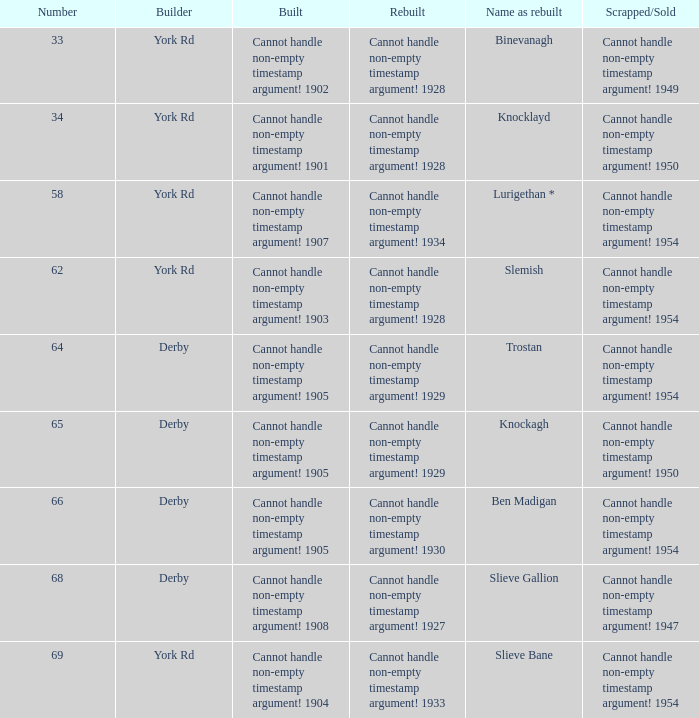Which Rebuilt has a Name as rebuilt of binevanagh? Cannot handle non-empty timestamp argument! 1928. 